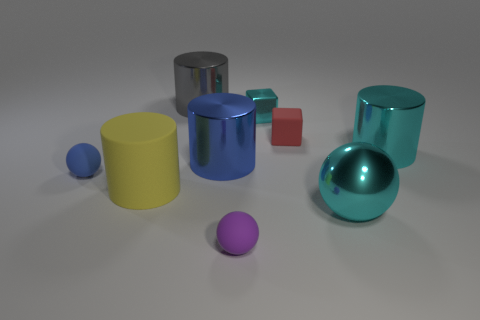Subtract 1 cylinders. How many cylinders are left? 3 Subtract all cylinders. How many objects are left? 5 Add 6 large rubber cylinders. How many large rubber cylinders are left? 7 Add 4 tiny shiny objects. How many tiny shiny objects exist? 5 Subtract 1 cyan cubes. How many objects are left? 8 Subtract all big yellow cylinders. Subtract all small red cubes. How many objects are left? 7 